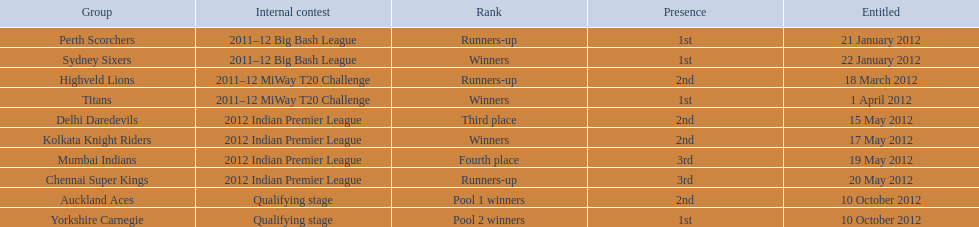What is the total number of teams? 10. 